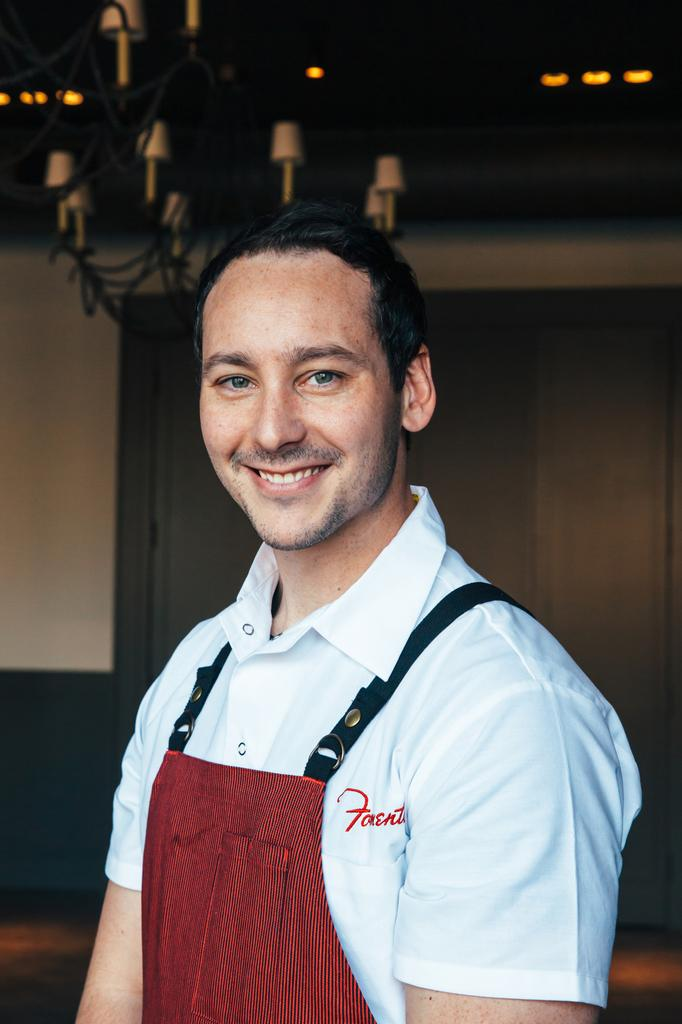<image>
Summarize the visual content of the image. A man wearing an apron has a logo with the letter F embroidered on his shirt. 